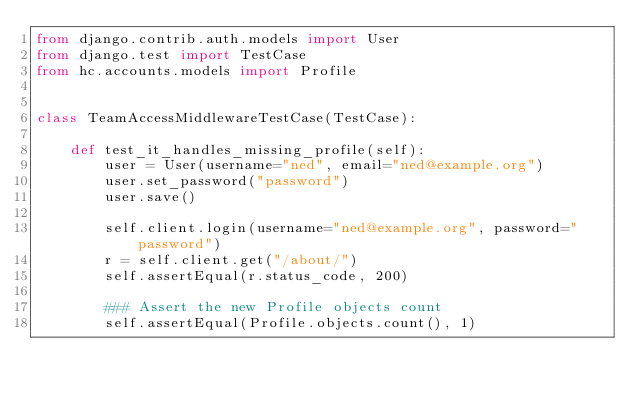<code> <loc_0><loc_0><loc_500><loc_500><_Python_>from django.contrib.auth.models import User
from django.test import TestCase
from hc.accounts.models import Profile


class TeamAccessMiddlewareTestCase(TestCase):

    def test_it_handles_missing_profile(self):
        user = User(username="ned", email="ned@example.org")
        user.set_password("password")
        user.save()

        self.client.login(username="ned@example.org", password="password")
        r = self.client.get("/about/")
        self.assertEqual(r.status_code, 200)

        ### Assert the new Profile objects count
        self.assertEqual(Profile.objects.count(), 1)
</code> 